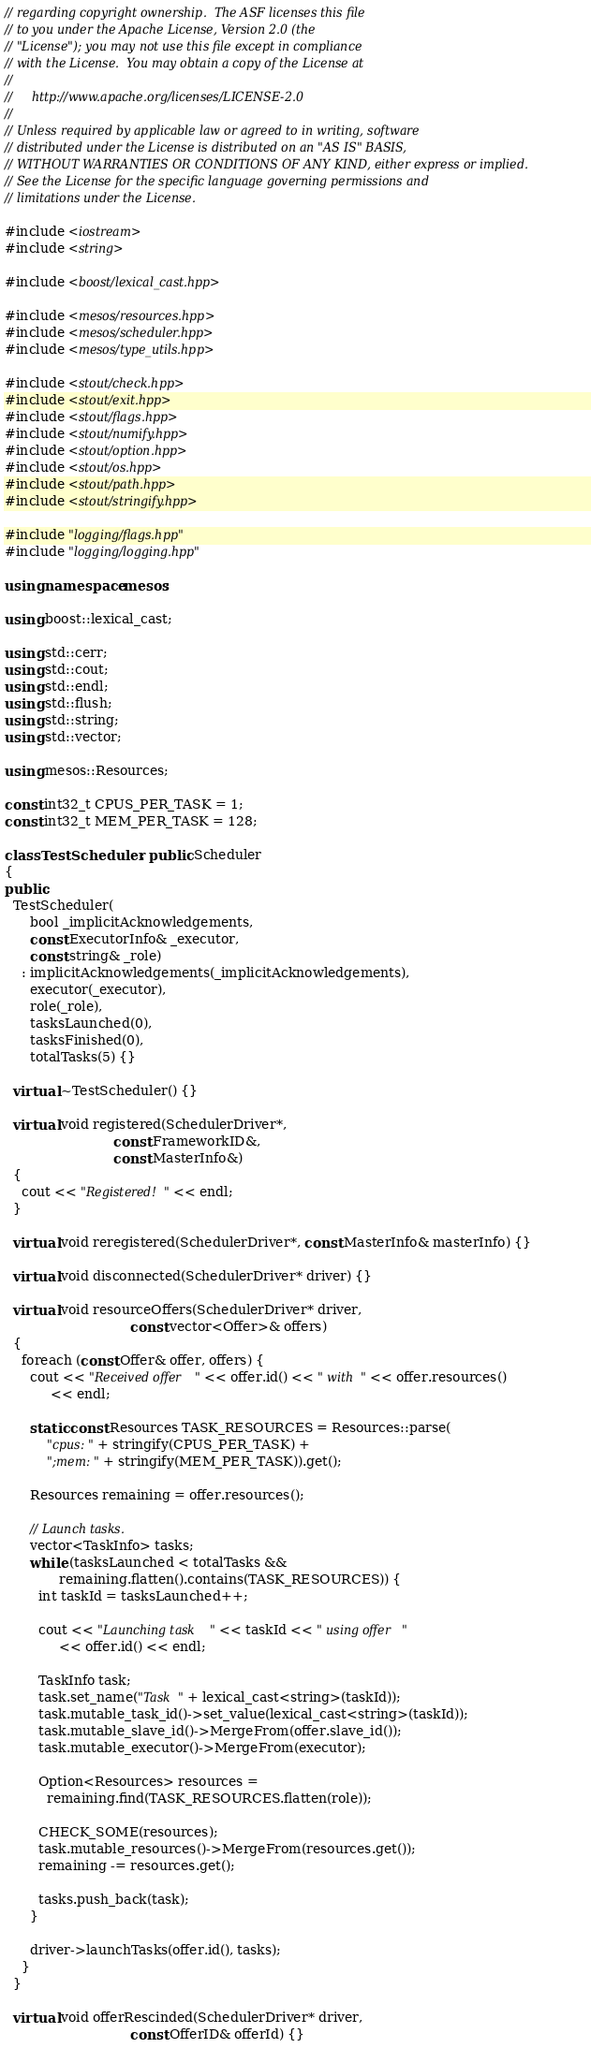<code> <loc_0><loc_0><loc_500><loc_500><_C++_>// regarding copyright ownership.  The ASF licenses this file
// to you under the Apache License, Version 2.0 (the
// "License"); you may not use this file except in compliance
// with the License.  You may obtain a copy of the License at
//
//     http://www.apache.org/licenses/LICENSE-2.0
//
// Unless required by applicable law or agreed to in writing, software
// distributed under the License is distributed on an "AS IS" BASIS,
// WITHOUT WARRANTIES OR CONDITIONS OF ANY KIND, either express or implied.
// See the License for the specific language governing permissions and
// limitations under the License.

#include <iostream>
#include <string>

#include <boost/lexical_cast.hpp>

#include <mesos/resources.hpp>
#include <mesos/scheduler.hpp>
#include <mesos/type_utils.hpp>

#include <stout/check.hpp>
#include <stout/exit.hpp>
#include <stout/flags.hpp>
#include <stout/numify.hpp>
#include <stout/option.hpp>
#include <stout/os.hpp>
#include <stout/path.hpp>
#include <stout/stringify.hpp>

#include "logging/flags.hpp"
#include "logging/logging.hpp"

using namespace mesos;

using boost::lexical_cast;

using std::cerr;
using std::cout;
using std::endl;
using std::flush;
using std::string;
using std::vector;

using mesos::Resources;

const int32_t CPUS_PER_TASK = 1;
const int32_t MEM_PER_TASK = 128;

class TestScheduler : public Scheduler
{
public:
  TestScheduler(
      bool _implicitAcknowledgements,
      const ExecutorInfo& _executor,
      const string& _role)
    : implicitAcknowledgements(_implicitAcknowledgements),
      executor(_executor),
      role(_role),
      tasksLaunched(0),
      tasksFinished(0),
      totalTasks(5) {}

  virtual ~TestScheduler() {}

  virtual void registered(SchedulerDriver*,
                          const FrameworkID&,
                          const MasterInfo&)
  {
    cout << "Registered!" << endl;
  }

  virtual void reregistered(SchedulerDriver*, const MasterInfo& masterInfo) {}

  virtual void disconnected(SchedulerDriver* driver) {}

  virtual void resourceOffers(SchedulerDriver* driver,
                              const vector<Offer>& offers)
  {
    foreach (const Offer& offer, offers) {
      cout << "Received offer " << offer.id() << " with " << offer.resources()
           << endl;

      static const Resources TASK_RESOURCES = Resources::parse(
          "cpus:" + stringify(CPUS_PER_TASK) +
          ";mem:" + stringify(MEM_PER_TASK)).get();

      Resources remaining = offer.resources();

      // Launch tasks.
      vector<TaskInfo> tasks;
      while (tasksLaunched < totalTasks &&
             remaining.flatten().contains(TASK_RESOURCES)) {
        int taskId = tasksLaunched++;

        cout << "Launching task " << taskId << " using offer "
             << offer.id() << endl;

        TaskInfo task;
        task.set_name("Task " + lexical_cast<string>(taskId));
        task.mutable_task_id()->set_value(lexical_cast<string>(taskId));
        task.mutable_slave_id()->MergeFrom(offer.slave_id());
        task.mutable_executor()->MergeFrom(executor);

        Option<Resources> resources =
          remaining.find(TASK_RESOURCES.flatten(role));

        CHECK_SOME(resources);
        task.mutable_resources()->MergeFrom(resources.get());
        remaining -= resources.get();

        tasks.push_back(task);
      }

      driver->launchTasks(offer.id(), tasks);
    }
  }

  virtual void offerRescinded(SchedulerDriver* driver,
                              const OfferID& offerId) {}
</code> 